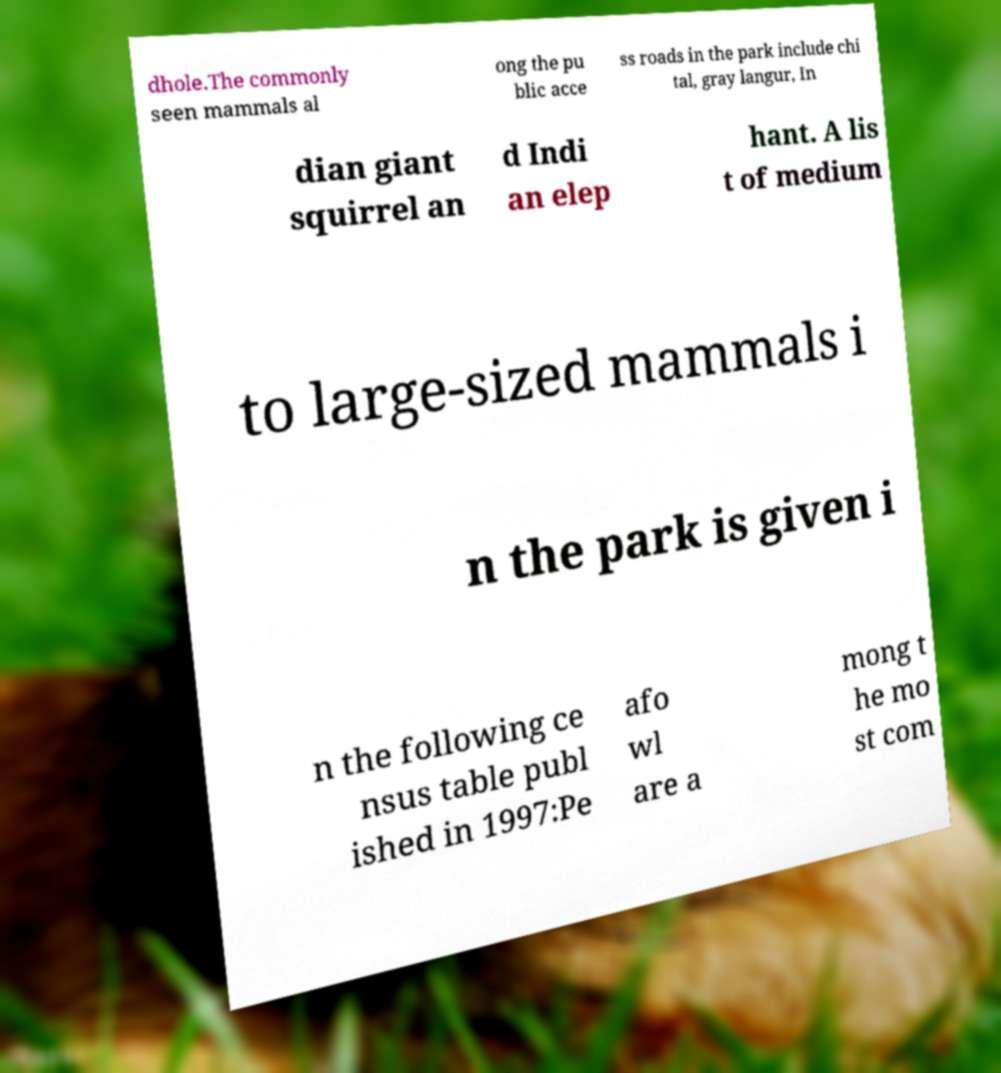Could you extract and type out the text from this image? dhole.The commonly seen mammals al ong the pu blic acce ss roads in the park include chi tal, gray langur, In dian giant squirrel an d Indi an elep hant. A lis t of medium to large-sized mammals i n the park is given i n the following ce nsus table publ ished in 1997:Pe afo wl are a mong t he mo st com 